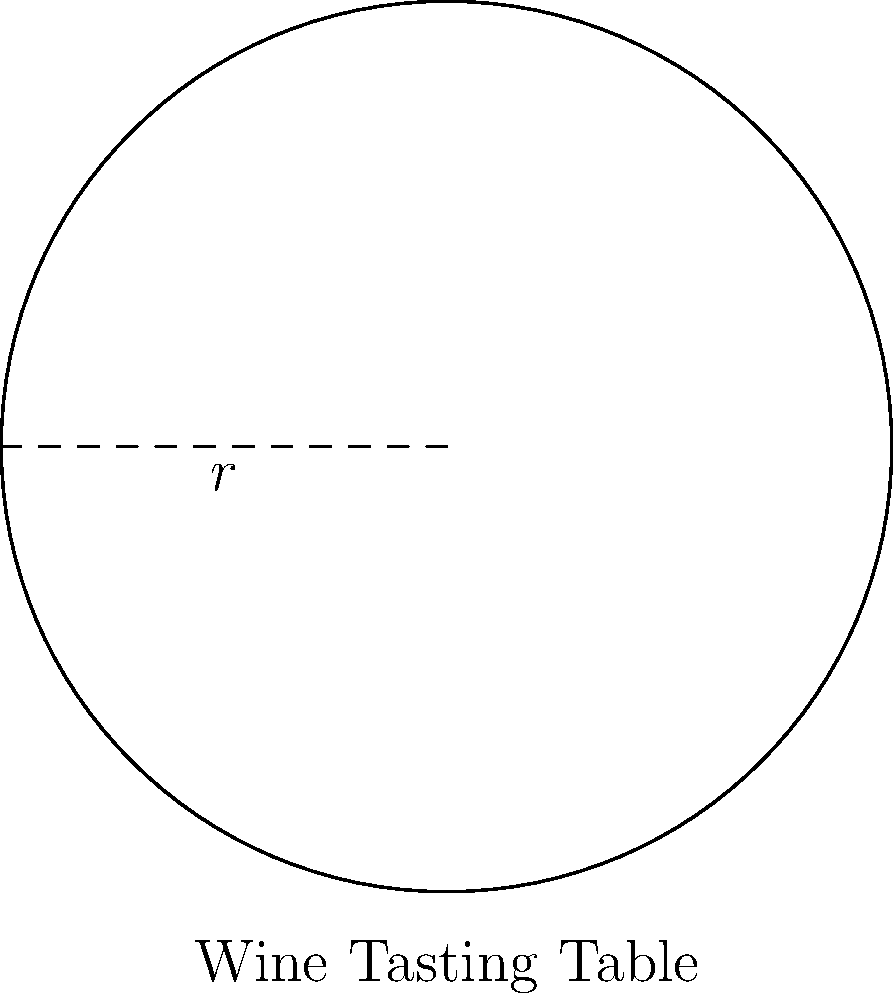As a wine enthusiast planning a tasting event, you've decided to use a circular table for your guests. If the table has a radius of 1.5 meters, what is its perimeter (to the nearest centimeter)? Consider using this information to determine how many people can comfortably sit around the table for the wine tasting session. To find the perimeter of a circular table, we need to calculate its circumference. The formula for the circumference of a circle is:

$$C = 2\pi r$$

Where:
$C$ = circumference
$\pi$ = pi (approximately 3.14159)
$r$ = radius

Given:
$r = 1.5$ meters

Let's calculate:

1) $C = 2\pi r$
2) $C = 2 \times 3.14159 \times 1.5$
3) $C = 9.42477$ meters

To convert to centimeters:
4) $9.42477 \text{ m} \times 100 \text{ cm/m} = 942.477 \text{ cm}$

Rounding to the nearest centimeter:
5) $942.477 \text{ cm} \approx 942 \text{ cm}$

This perimeter can help determine the number of guests. Typically, each person needs about 60-75 cm of space for comfortable seating at a dining table. So, this table could accommodate approximately 12-15 people for a cozy wine tasting experience.
Answer: 942 cm 